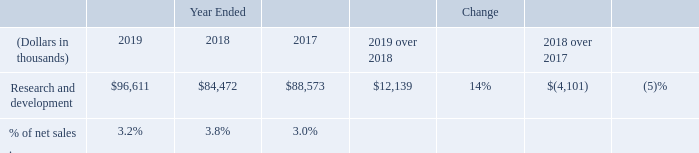Research and development
Research and development expense consists primarily of salaries and other personnel-related costs; the cost of products, materials, and outside services used in our R&D activities; and depreciation and amortization expense associated with R&D specific facilities and equipment. We maintain a number of programs and activities to improve our technology and processes in order to enhance the performance and reduce the costs of our solar modules.
The following table shows research and development expense for the years ended December 31, 2019, 2018, and 2017:
Research and development expense in 2019 increased compared to 2018 primarily due to increased material and module testing costs and higher employee compensation expense.
What are the reasons for higher research and development expense in 2019? Research and development expense in 2019 increased compared to 2018 primarily due to increased material and module testing costs and higher employee compensation expense. What is the percentage of net sales in 2017? 3.0%. What are components of research and development expense? Research and development expense consists primarily of salaries and other personnel-related costs; the cost of products, materials, and outside services used in our r&d activities; and depreciation and amortization expense associated with r&d specific facilities and equipment. What is the amount of net sales derived in 2017?
Answer scale should be: thousand. 88,573 / 3.0% 
Answer: 2952433.33. What is the net difference in research and development expense between 2019 and 2017?
Answer scale should be: thousand. 96,611 - 88,573 
Answer: 8038. What is the difference in net sales amount between 2018 and 2017?
Answer scale should be: thousand. (84,472 / 3.8%) - (88,573 / 3.0%) 
Answer: -729485.96. 